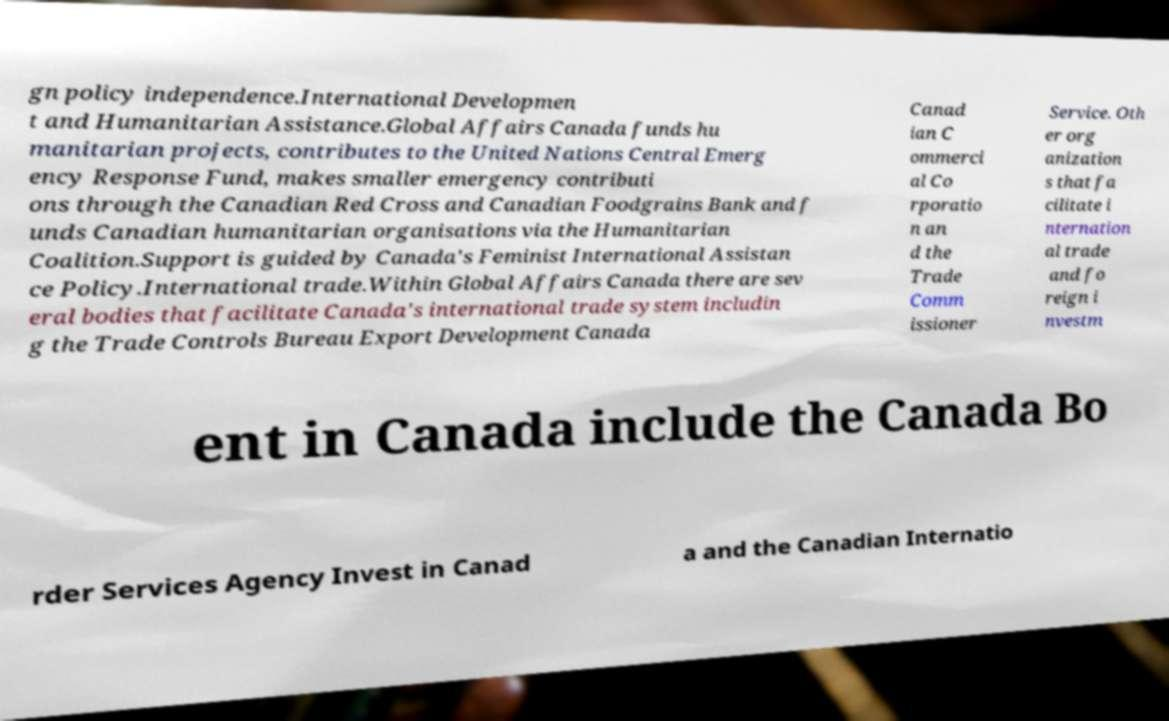I need the written content from this picture converted into text. Can you do that? gn policy independence.International Developmen t and Humanitarian Assistance.Global Affairs Canada funds hu manitarian projects, contributes to the United Nations Central Emerg ency Response Fund, makes smaller emergency contributi ons through the Canadian Red Cross and Canadian Foodgrains Bank and f unds Canadian humanitarian organisations via the Humanitarian Coalition.Support is guided by Canada's Feminist International Assistan ce Policy.International trade.Within Global Affairs Canada there are sev eral bodies that facilitate Canada's international trade system includin g the Trade Controls Bureau Export Development Canada Canad ian C ommerci al Co rporatio n an d the Trade Comm issioner Service. Oth er org anization s that fa cilitate i nternation al trade and fo reign i nvestm ent in Canada include the Canada Bo rder Services Agency Invest in Canad a and the Canadian Internatio 